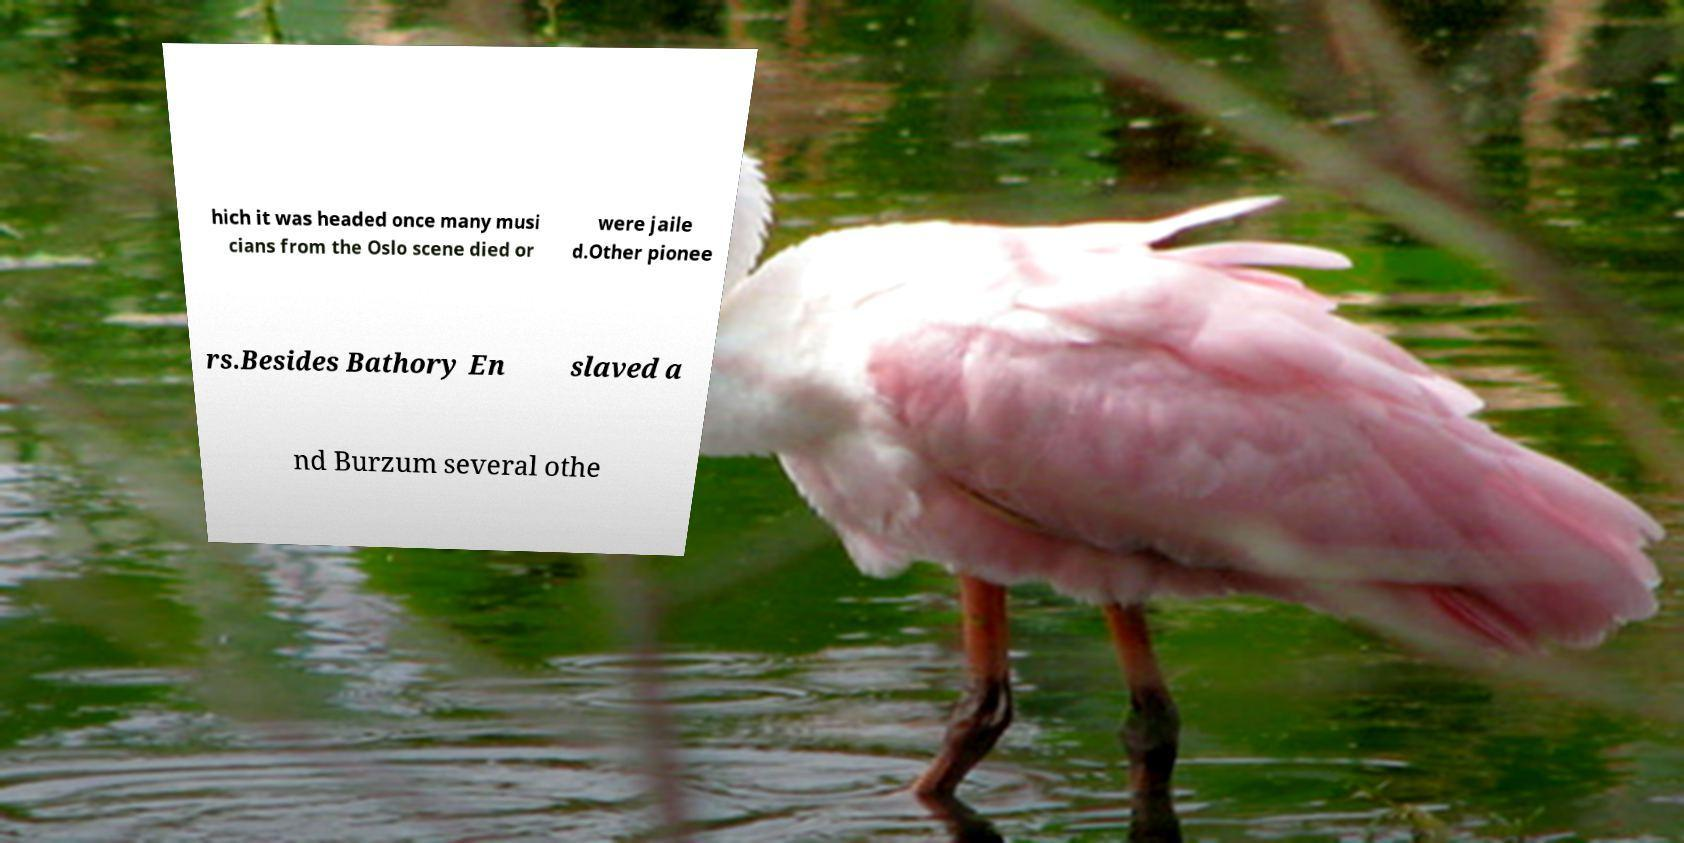There's text embedded in this image that I need extracted. Can you transcribe it verbatim? hich it was headed once many musi cians from the Oslo scene died or were jaile d.Other pionee rs.Besides Bathory En slaved a nd Burzum several othe 